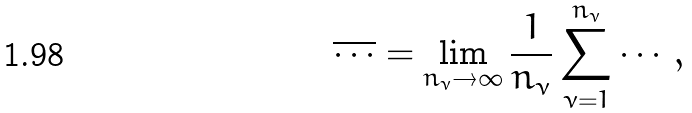Convert formula to latex. <formula><loc_0><loc_0><loc_500><loc_500>\overline { \cdots } = \lim _ { n _ { \nu } \to \infty } \frac { 1 } { n _ { \nu } } \sum _ { \nu = 1 } ^ { n _ { \nu } } \cdots ,</formula> 